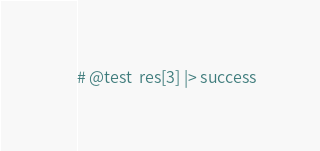<code> <loc_0><loc_0><loc_500><loc_500><_Julia_># @test  res[3] |> success
</code> 